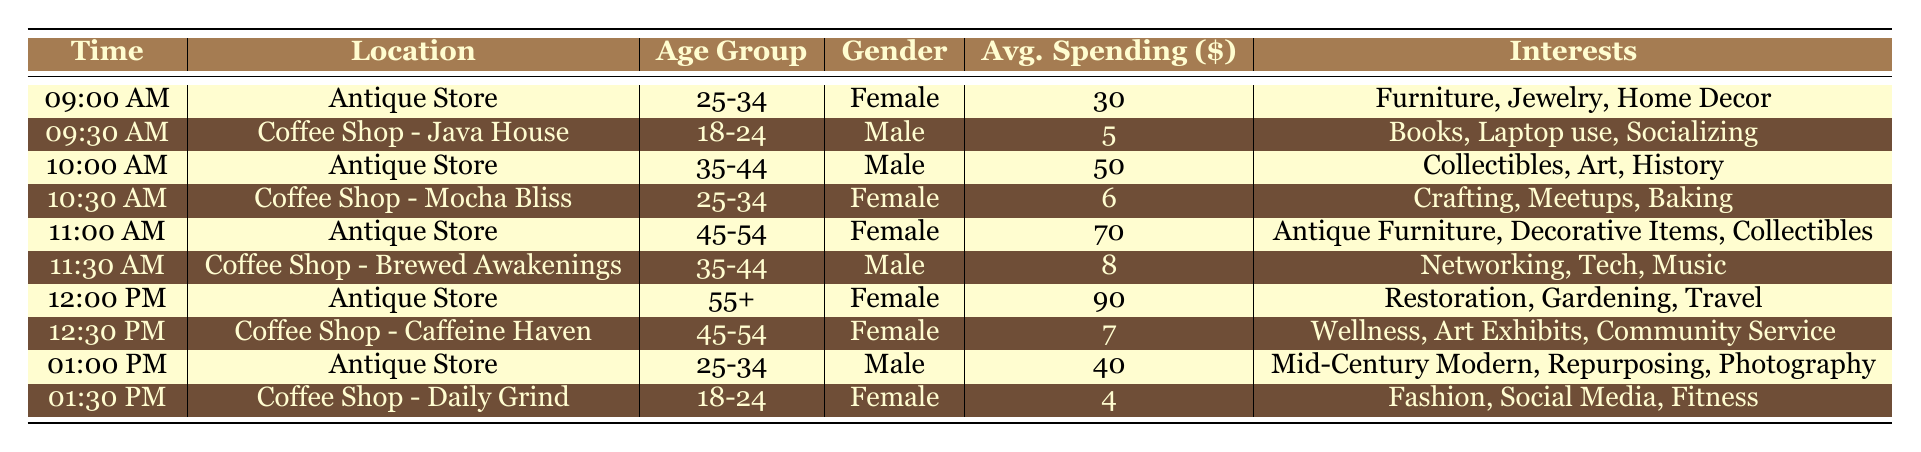What is the average spending of customers at the Antique Store? To find the average spending at the Antique Store, we look at the spending values: 30, 50, 70, 90, and 40. We sum these values: 30 + 50 + 70 + 90 + 40 = 280. There are 5 data points, so the average is 280 / 5 = 56.
Answer: 56 Which coffee shop has customers with the highest average spending? The average spending values for the coffee shops are: 5 at Java House, 6 at Mocha Bliss, 8 at Brewed Awakenings, and 7 at Caffeine Haven. The highest value is 8 from Brewed Awakenings.
Answer: Brewed Awakenings Are there more male customers visiting the Antique Store than the coffee shops? We have the following gender counts: Antique Store: Male (2) and Female (3), Coffee Shops: Male (2) and Female (4). Comparing these, Antique Store has 2 males, and coffee shops have 2 males, so they are equal.
Answer: No What age group spends the most at the Antique Store? We examine the spending amounts per age group: 25-34 (30), 35-44 (50), 45-54 (70), 55+ (90), and 25-34 (40). The maximum spending is 90 from the age group 55+.
Answer: 55+ What is the total average spending of all customers at the coffee shops? The average spending at each coffee shop is 5, 6, 8, and 7. We sum these values: 5 + 6 + 8 + 7 = 26, and there are 4 data points, so the total average is 26 / 4 = 6.5.
Answer: 6.5 Do all customers at the Antique Store have spending over $30? The spending amounts at the Antique Store are 30, 50, 70, 90, and 40. One customer has a spending of exactly 30, so not all customers spend over 30.
Answer: No What percentage of the customers at the Antique Store are female? The total number of customers at the Antique Store is 5, with 3 being female. To calculate the percentage of female customers, we do (3/5) * 100 = 60%.
Answer: 60% Which age group spends at least $70 at the Antique Store? The age groups with spending amounts are: 25-34 (30), 35-44 (50), 45-54 (70), and 55+ (90). The age groups spending at least $70 are 45-54 and 55+.
Answer: 45-54, 55+ Are the interests of customers at coffee shops more related to social activities compared to those at the Antique Store? The coffee shop interests include social activities such as socializing and meetups, while Antique Store interests focus on collecting and decorating. Given the context, coffee shop customers appear to have interests more aligned with social activities than Antique Store customers.
Answer: Yes 